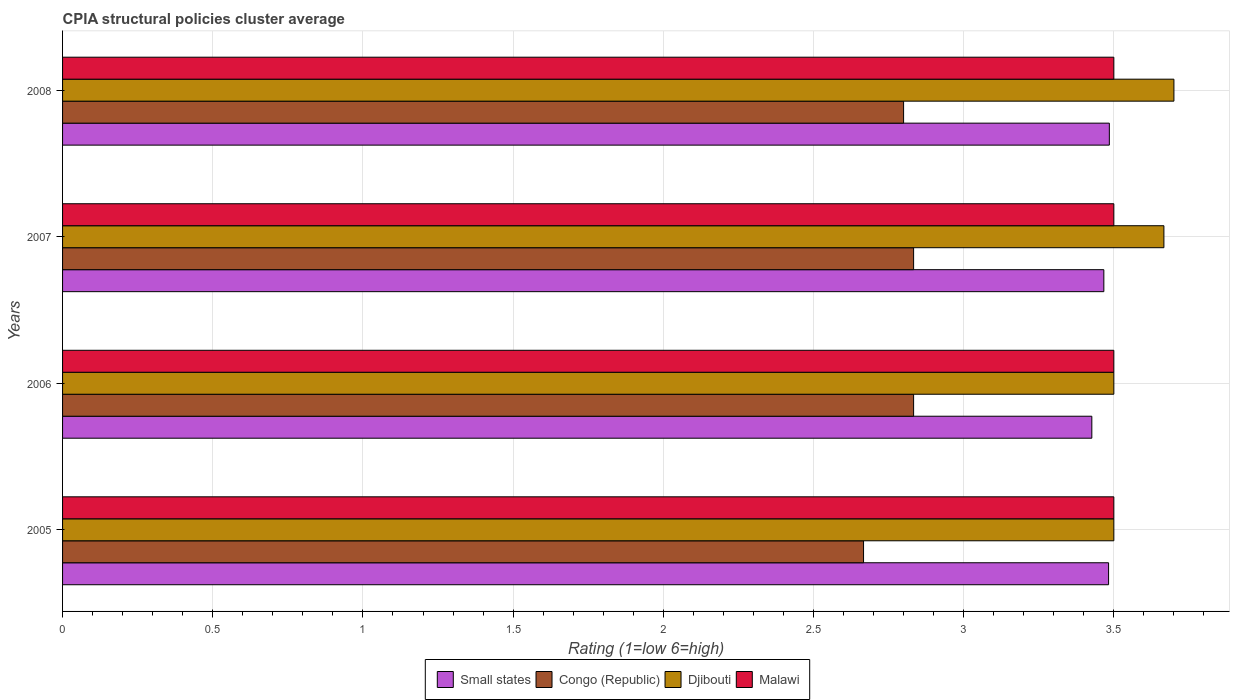How many different coloured bars are there?
Offer a very short reply. 4. How many groups of bars are there?
Your answer should be compact. 4. Are the number of bars per tick equal to the number of legend labels?
Offer a very short reply. Yes. Are the number of bars on each tick of the Y-axis equal?
Your answer should be very brief. Yes. How many bars are there on the 4th tick from the top?
Provide a succinct answer. 4. In how many cases, is the number of bars for a given year not equal to the number of legend labels?
Provide a short and direct response. 0. What is the CPIA rating in Small states in 2007?
Your answer should be compact. 3.47. Across all years, what is the maximum CPIA rating in Congo (Republic)?
Make the answer very short. 2.83. Across all years, what is the minimum CPIA rating in Malawi?
Ensure brevity in your answer.  3.5. What is the total CPIA rating in Small states in the graph?
Make the answer very short. 13.86. What is the difference between the CPIA rating in Congo (Republic) in 2007 and that in 2008?
Provide a short and direct response. 0.03. What is the difference between the CPIA rating in Malawi in 2006 and the CPIA rating in Congo (Republic) in 2005?
Give a very brief answer. 0.83. What is the average CPIA rating in Small states per year?
Your answer should be very brief. 3.47. In the year 2007, what is the difference between the CPIA rating in Small states and CPIA rating in Congo (Republic)?
Ensure brevity in your answer.  0.63. What is the ratio of the CPIA rating in Congo (Republic) in 2007 to that in 2008?
Provide a succinct answer. 1.01. Is the CPIA rating in Small states in 2007 less than that in 2008?
Keep it short and to the point. Yes. Is the difference between the CPIA rating in Small states in 2005 and 2006 greater than the difference between the CPIA rating in Congo (Republic) in 2005 and 2006?
Offer a terse response. Yes. What is the difference between the highest and the lowest CPIA rating in Small states?
Offer a very short reply. 0.06. Is the sum of the CPIA rating in Congo (Republic) in 2006 and 2008 greater than the maximum CPIA rating in Malawi across all years?
Provide a short and direct response. Yes. Is it the case that in every year, the sum of the CPIA rating in Small states and CPIA rating in Congo (Republic) is greater than the sum of CPIA rating in Djibouti and CPIA rating in Malawi?
Keep it short and to the point. Yes. What does the 2nd bar from the top in 2007 represents?
Make the answer very short. Djibouti. What does the 1st bar from the bottom in 2008 represents?
Your response must be concise. Small states. Is it the case that in every year, the sum of the CPIA rating in Small states and CPIA rating in Congo (Republic) is greater than the CPIA rating in Malawi?
Give a very brief answer. Yes. Are all the bars in the graph horizontal?
Provide a short and direct response. Yes. How many years are there in the graph?
Your response must be concise. 4. What is the title of the graph?
Provide a succinct answer. CPIA structural policies cluster average. Does "Barbados" appear as one of the legend labels in the graph?
Ensure brevity in your answer.  No. What is the label or title of the X-axis?
Make the answer very short. Rating (1=low 6=high). What is the Rating (1=low 6=high) in Small states in 2005?
Your answer should be compact. 3.48. What is the Rating (1=low 6=high) of Congo (Republic) in 2005?
Ensure brevity in your answer.  2.67. What is the Rating (1=low 6=high) in Djibouti in 2005?
Your answer should be compact. 3.5. What is the Rating (1=low 6=high) in Malawi in 2005?
Make the answer very short. 3.5. What is the Rating (1=low 6=high) of Small states in 2006?
Give a very brief answer. 3.43. What is the Rating (1=low 6=high) of Congo (Republic) in 2006?
Keep it short and to the point. 2.83. What is the Rating (1=low 6=high) in Djibouti in 2006?
Offer a terse response. 3.5. What is the Rating (1=low 6=high) of Malawi in 2006?
Make the answer very short. 3.5. What is the Rating (1=low 6=high) in Small states in 2007?
Your answer should be very brief. 3.47. What is the Rating (1=low 6=high) of Congo (Republic) in 2007?
Your answer should be compact. 2.83. What is the Rating (1=low 6=high) of Djibouti in 2007?
Your answer should be compact. 3.67. What is the Rating (1=low 6=high) in Malawi in 2007?
Offer a terse response. 3.5. What is the Rating (1=low 6=high) of Small states in 2008?
Offer a very short reply. 3.48. What is the Rating (1=low 6=high) in Malawi in 2008?
Keep it short and to the point. 3.5. Across all years, what is the maximum Rating (1=low 6=high) in Small states?
Keep it short and to the point. 3.48. Across all years, what is the maximum Rating (1=low 6=high) in Congo (Republic)?
Ensure brevity in your answer.  2.83. Across all years, what is the maximum Rating (1=low 6=high) in Djibouti?
Offer a terse response. 3.7. Across all years, what is the minimum Rating (1=low 6=high) in Small states?
Offer a terse response. 3.43. Across all years, what is the minimum Rating (1=low 6=high) of Congo (Republic)?
Your answer should be very brief. 2.67. Across all years, what is the minimum Rating (1=low 6=high) of Djibouti?
Offer a very short reply. 3.5. What is the total Rating (1=low 6=high) of Small states in the graph?
Give a very brief answer. 13.86. What is the total Rating (1=low 6=high) of Congo (Republic) in the graph?
Give a very brief answer. 11.13. What is the total Rating (1=low 6=high) of Djibouti in the graph?
Make the answer very short. 14.37. What is the difference between the Rating (1=low 6=high) in Small states in 2005 and that in 2006?
Provide a succinct answer. 0.06. What is the difference between the Rating (1=low 6=high) of Congo (Republic) in 2005 and that in 2006?
Offer a very short reply. -0.17. What is the difference between the Rating (1=low 6=high) in Small states in 2005 and that in 2007?
Your answer should be compact. 0.02. What is the difference between the Rating (1=low 6=high) of Congo (Republic) in 2005 and that in 2007?
Keep it short and to the point. -0.17. What is the difference between the Rating (1=low 6=high) in Djibouti in 2005 and that in 2007?
Your response must be concise. -0.17. What is the difference between the Rating (1=low 6=high) of Malawi in 2005 and that in 2007?
Offer a terse response. 0. What is the difference between the Rating (1=low 6=high) in Small states in 2005 and that in 2008?
Ensure brevity in your answer.  -0. What is the difference between the Rating (1=low 6=high) in Congo (Republic) in 2005 and that in 2008?
Your answer should be compact. -0.13. What is the difference between the Rating (1=low 6=high) of Small states in 2006 and that in 2007?
Provide a succinct answer. -0.04. What is the difference between the Rating (1=low 6=high) of Djibouti in 2006 and that in 2007?
Keep it short and to the point. -0.17. What is the difference between the Rating (1=low 6=high) of Small states in 2006 and that in 2008?
Your answer should be very brief. -0.06. What is the difference between the Rating (1=low 6=high) in Small states in 2007 and that in 2008?
Your response must be concise. -0.02. What is the difference between the Rating (1=low 6=high) in Congo (Republic) in 2007 and that in 2008?
Your answer should be compact. 0.03. What is the difference between the Rating (1=low 6=high) in Djibouti in 2007 and that in 2008?
Ensure brevity in your answer.  -0.03. What is the difference between the Rating (1=low 6=high) in Small states in 2005 and the Rating (1=low 6=high) in Congo (Republic) in 2006?
Keep it short and to the point. 0.65. What is the difference between the Rating (1=low 6=high) of Small states in 2005 and the Rating (1=low 6=high) of Djibouti in 2006?
Your answer should be very brief. -0.02. What is the difference between the Rating (1=low 6=high) of Small states in 2005 and the Rating (1=low 6=high) of Malawi in 2006?
Offer a very short reply. -0.02. What is the difference between the Rating (1=low 6=high) in Djibouti in 2005 and the Rating (1=low 6=high) in Malawi in 2006?
Make the answer very short. 0. What is the difference between the Rating (1=low 6=high) of Small states in 2005 and the Rating (1=low 6=high) of Congo (Republic) in 2007?
Ensure brevity in your answer.  0.65. What is the difference between the Rating (1=low 6=high) in Small states in 2005 and the Rating (1=low 6=high) in Djibouti in 2007?
Provide a short and direct response. -0.18. What is the difference between the Rating (1=low 6=high) of Small states in 2005 and the Rating (1=low 6=high) of Malawi in 2007?
Offer a very short reply. -0.02. What is the difference between the Rating (1=low 6=high) in Congo (Republic) in 2005 and the Rating (1=low 6=high) in Djibouti in 2007?
Make the answer very short. -1. What is the difference between the Rating (1=low 6=high) of Congo (Republic) in 2005 and the Rating (1=low 6=high) of Malawi in 2007?
Provide a short and direct response. -0.83. What is the difference between the Rating (1=low 6=high) in Djibouti in 2005 and the Rating (1=low 6=high) in Malawi in 2007?
Make the answer very short. 0. What is the difference between the Rating (1=low 6=high) of Small states in 2005 and the Rating (1=low 6=high) of Congo (Republic) in 2008?
Your answer should be very brief. 0.68. What is the difference between the Rating (1=low 6=high) of Small states in 2005 and the Rating (1=low 6=high) of Djibouti in 2008?
Your answer should be compact. -0.22. What is the difference between the Rating (1=low 6=high) in Small states in 2005 and the Rating (1=low 6=high) in Malawi in 2008?
Make the answer very short. -0.02. What is the difference between the Rating (1=low 6=high) in Congo (Republic) in 2005 and the Rating (1=low 6=high) in Djibouti in 2008?
Provide a succinct answer. -1.03. What is the difference between the Rating (1=low 6=high) of Djibouti in 2005 and the Rating (1=low 6=high) of Malawi in 2008?
Give a very brief answer. 0. What is the difference between the Rating (1=low 6=high) of Small states in 2006 and the Rating (1=low 6=high) of Congo (Republic) in 2007?
Your response must be concise. 0.59. What is the difference between the Rating (1=low 6=high) in Small states in 2006 and the Rating (1=low 6=high) in Djibouti in 2007?
Your answer should be very brief. -0.24. What is the difference between the Rating (1=low 6=high) of Small states in 2006 and the Rating (1=low 6=high) of Malawi in 2007?
Offer a terse response. -0.07. What is the difference between the Rating (1=low 6=high) of Congo (Republic) in 2006 and the Rating (1=low 6=high) of Malawi in 2007?
Provide a succinct answer. -0.67. What is the difference between the Rating (1=low 6=high) of Djibouti in 2006 and the Rating (1=low 6=high) of Malawi in 2007?
Provide a succinct answer. 0. What is the difference between the Rating (1=low 6=high) in Small states in 2006 and the Rating (1=low 6=high) in Congo (Republic) in 2008?
Make the answer very short. 0.63. What is the difference between the Rating (1=low 6=high) of Small states in 2006 and the Rating (1=low 6=high) of Djibouti in 2008?
Your answer should be very brief. -0.27. What is the difference between the Rating (1=low 6=high) in Small states in 2006 and the Rating (1=low 6=high) in Malawi in 2008?
Provide a succinct answer. -0.07. What is the difference between the Rating (1=low 6=high) in Congo (Republic) in 2006 and the Rating (1=low 6=high) in Djibouti in 2008?
Your answer should be compact. -0.87. What is the difference between the Rating (1=low 6=high) in Small states in 2007 and the Rating (1=low 6=high) in Congo (Republic) in 2008?
Your response must be concise. 0.67. What is the difference between the Rating (1=low 6=high) of Small states in 2007 and the Rating (1=low 6=high) of Djibouti in 2008?
Keep it short and to the point. -0.23. What is the difference between the Rating (1=low 6=high) of Small states in 2007 and the Rating (1=low 6=high) of Malawi in 2008?
Give a very brief answer. -0.03. What is the difference between the Rating (1=low 6=high) of Congo (Republic) in 2007 and the Rating (1=low 6=high) of Djibouti in 2008?
Your answer should be very brief. -0.87. What is the difference between the Rating (1=low 6=high) in Djibouti in 2007 and the Rating (1=low 6=high) in Malawi in 2008?
Your answer should be compact. 0.17. What is the average Rating (1=low 6=high) of Small states per year?
Ensure brevity in your answer.  3.47. What is the average Rating (1=low 6=high) in Congo (Republic) per year?
Ensure brevity in your answer.  2.78. What is the average Rating (1=low 6=high) in Djibouti per year?
Your answer should be very brief. 3.59. What is the average Rating (1=low 6=high) of Malawi per year?
Give a very brief answer. 3.5. In the year 2005, what is the difference between the Rating (1=low 6=high) of Small states and Rating (1=low 6=high) of Congo (Republic)?
Keep it short and to the point. 0.82. In the year 2005, what is the difference between the Rating (1=low 6=high) in Small states and Rating (1=low 6=high) in Djibouti?
Make the answer very short. -0.02. In the year 2005, what is the difference between the Rating (1=low 6=high) in Small states and Rating (1=low 6=high) in Malawi?
Ensure brevity in your answer.  -0.02. In the year 2005, what is the difference between the Rating (1=low 6=high) of Congo (Republic) and Rating (1=low 6=high) of Djibouti?
Give a very brief answer. -0.83. In the year 2005, what is the difference between the Rating (1=low 6=high) in Congo (Republic) and Rating (1=low 6=high) in Malawi?
Provide a succinct answer. -0.83. In the year 2006, what is the difference between the Rating (1=low 6=high) in Small states and Rating (1=low 6=high) in Congo (Republic)?
Offer a terse response. 0.59. In the year 2006, what is the difference between the Rating (1=low 6=high) of Small states and Rating (1=low 6=high) of Djibouti?
Provide a short and direct response. -0.07. In the year 2006, what is the difference between the Rating (1=low 6=high) of Small states and Rating (1=low 6=high) of Malawi?
Your response must be concise. -0.07. In the year 2006, what is the difference between the Rating (1=low 6=high) in Djibouti and Rating (1=low 6=high) in Malawi?
Offer a terse response. 0. In the year 2007, what is the difference between the Rating (1=low 6=high) of Small states and Rating (1=low 6=high) of Congo (Republic)?
Give a very brief answer. 0.63. In the year 2007, what is the difference between the Rating (1=low 6=high) of Small states and Rating (1=low 6=high) of Djibouti?
Offer a very short reply. -0.2. In the year 2007, what is the difference between the Rating (1=low 6=high) of Small states and Rating (1=low 6=high) of Malawi?
Your response must be concise. -0.03. In the year 2008, what is the difference between the Rating (1=low 6=high) in Small states and Rating (1=low 6=high) in Congo (Republic)?
Ensure brevity in your answer.  0.69. In the year 2008, what is the difference between the Rating (1=low 6=high) of Small states and Rating (1=low 6=high) of Djibouti?
Your answer should be very brief. -0.21. In the year 2008, what is the difference between the Rating (1=low 6=high) in Small states and Rating (1=low 6=high) in Malawi?
Make the answer very short. -0.01. In the year 2008, what is the difference between the Rating (1=low 6=high) in Congo (Republic) and Rating (1=low 6=high) in Malawi?
Provide a short and direct response. -0.7. What is the ratio of the Rating (1=low 6=high) in Small states in 2005 to that in 2006?
Offer a very short reply. 1.02. What is the ratio of the Rating (1=low 6=high) of Djibouti in 2005 to that in 2007?
Offer a terse response. 0.95. What is the ratio of the Rating (1=low 6=high) in Djibouti in 2005 to that in 2008?
Keep it short and to the point. 0.95. What is the ratio of the Rating (1=low 6=high) in Congo (Republic) in 2006 to that in 2007?
Provide a succinct answer. 1. What is the ratio of the Rating (1=low 6=high) in Djibouti in 2006 to that in 2007?
Offer a very short reply. 0.95. What is the ratio of the Rating (1=low 6=high) in Small states in 2006 to that in 2008?
Give a very brief answer. 0.98. What is the ratio of the Rating (1=low 6=high) in Congo (Republic) in 2006 to that in 2008?
Ensure brevity in your answer.  1.01. What is the ratio of the Rating (1=low 6=high) in Djibouti in 2006 to that in 2008?
Provide a short and direct response. 0.95. What is the ratio of the Rating (1=low 6=high) in Malawi in 2006 to that in 2008?
Make the answer very short. 1. What is the ratio of the Rating (1=low 6=high) of Congo (Republic) in 2007 to that in 2008?
Give a very brief answer. 1.01. What is the ratio of the Rating (1=low 6=high) of Malawi in 2007 to that in 2008?
Your answer should be very brief. 1. What is the difference between the highest and the second highest Rating (1=low 6=high) in Small states?
Make the answer very short. 0. What is the difference between the highest and the second highest Rating (1=low 6=high) in Congo (Republic)?
Provide a short and direct response. 0. What is the difference between the highest and the second highest Rating (1=low 6=high) of Djibouti?
Keep it short and to the point. 0.03. What is the difference between the highest and the lowest Rating (1=low 6=high) in Small states?
Offer a very short reply. 0.06. What is the difference between the highest and the lowest Rating (1=low 6=high) in Congo (Republic)?
Make the answer very short. 0.17. 